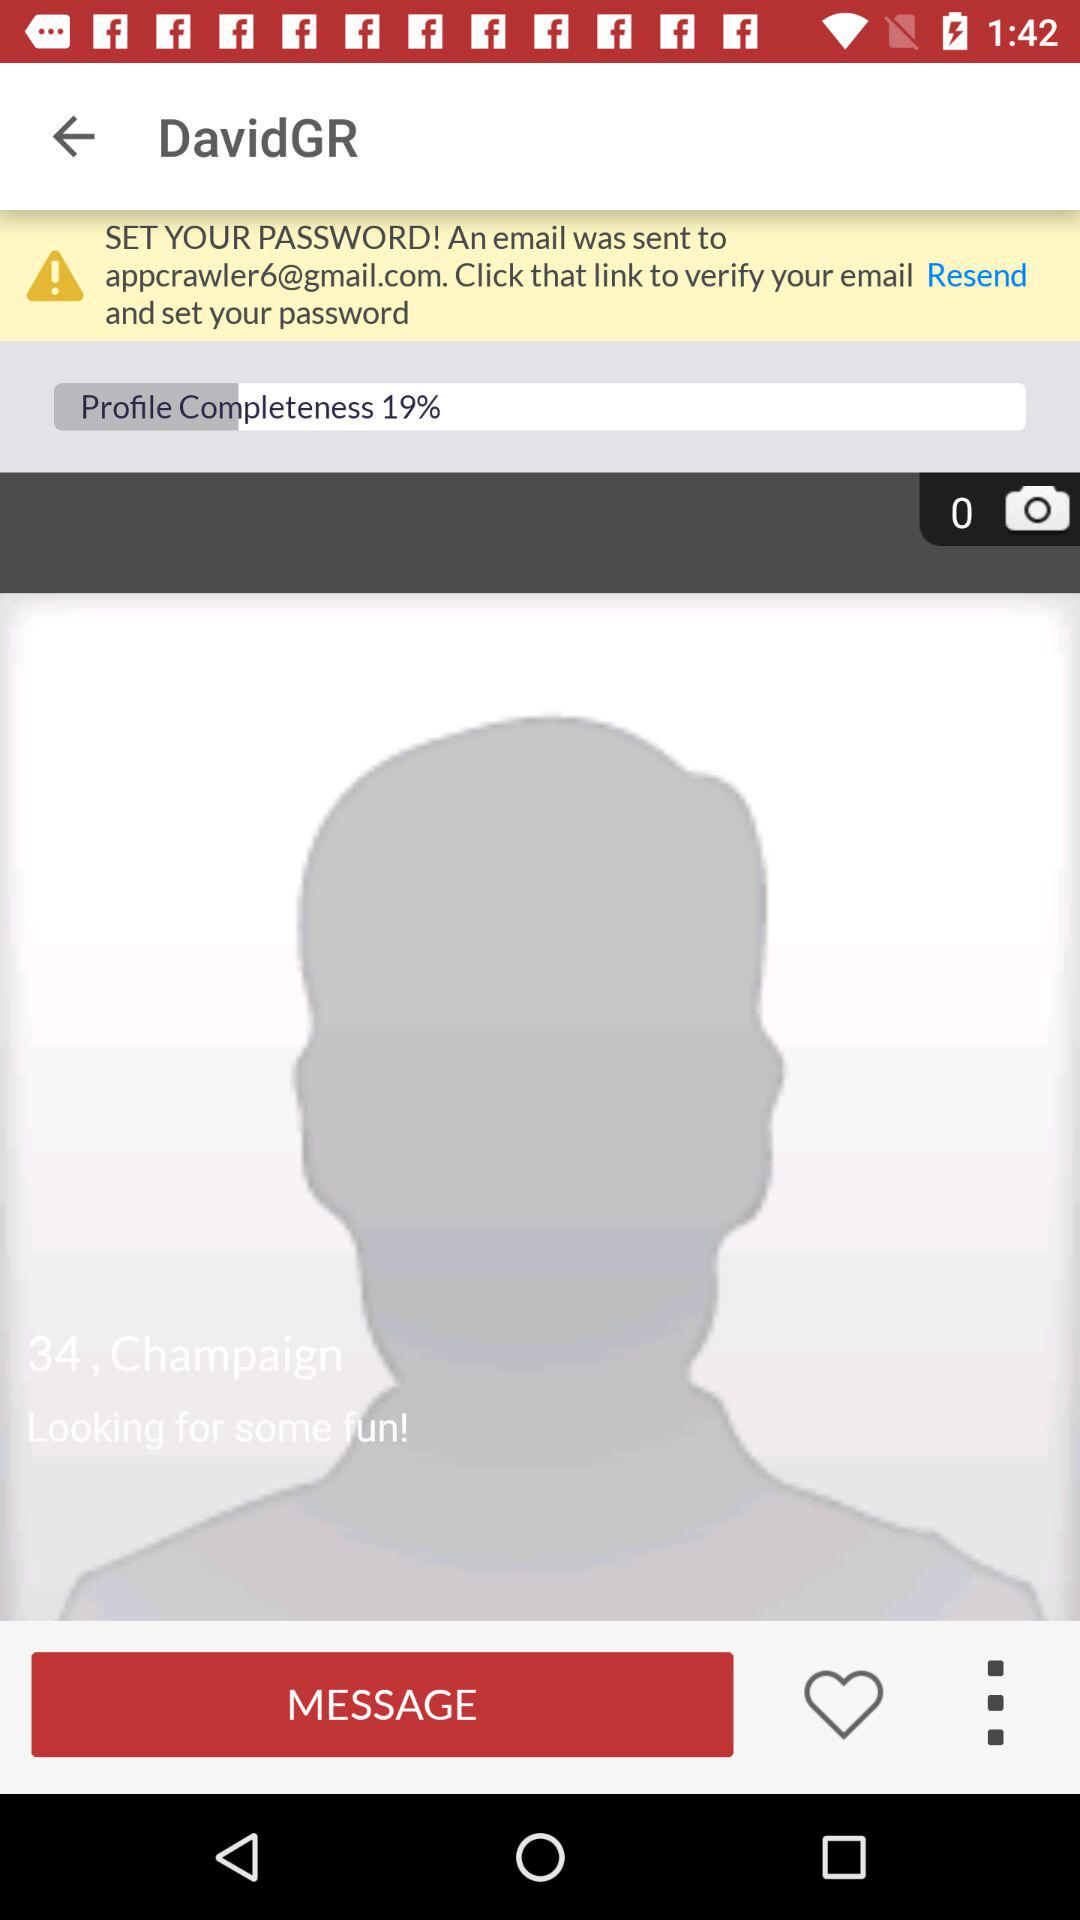What is the username? The username is "DavidGR". 